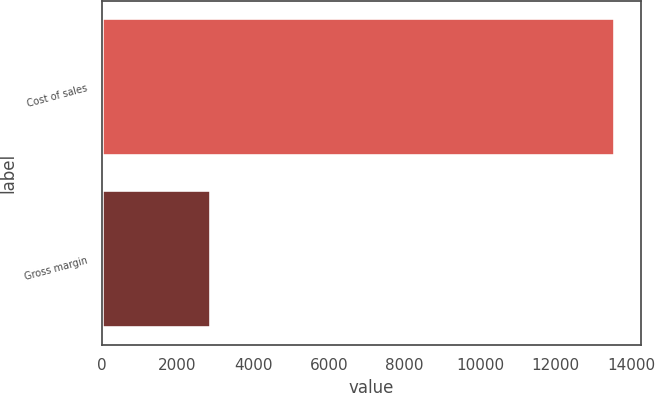Convert chart. <chart><loc_0><loc_0><loc_500><loc_500><bar_chart><fcel>Cost of sales<fcel>Gross margin<nl><fcel>13567<fcel>2896<nl></chart> 